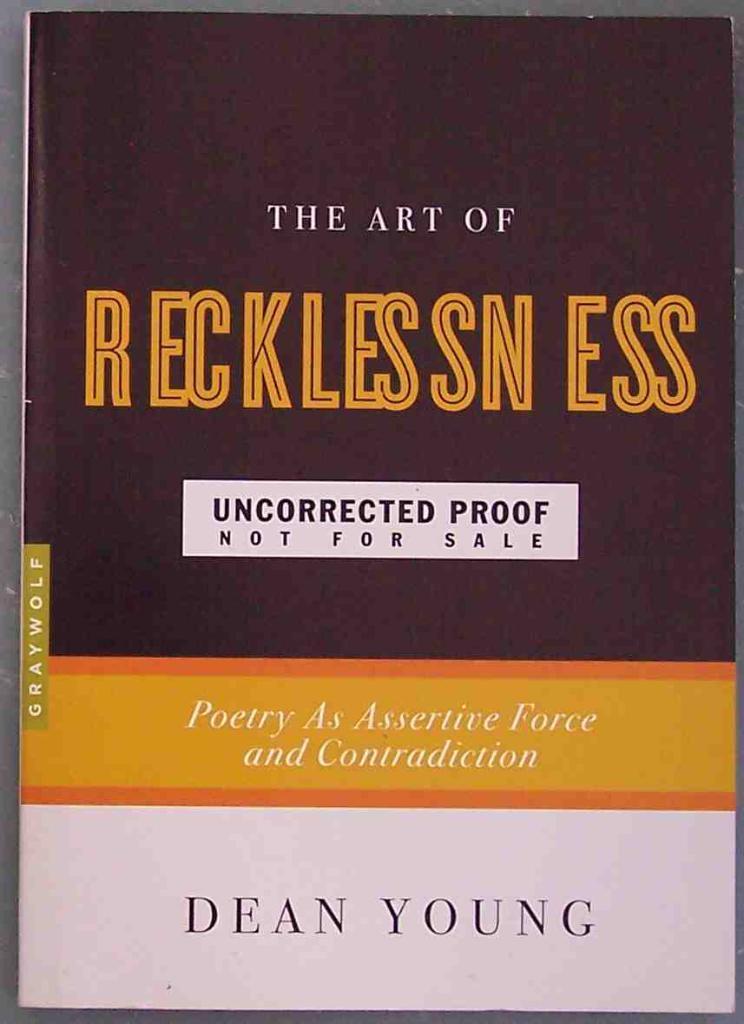What is the title of this book by dean young?
Your answer should be very brief. The art of recklessness. Was this published by graywolf?
Keep it short and to the point. Yes. 